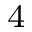Convert formula to latex. <formula><loc_0><loc_0><loc_500><loc_500>^ { 4 }</formula> 